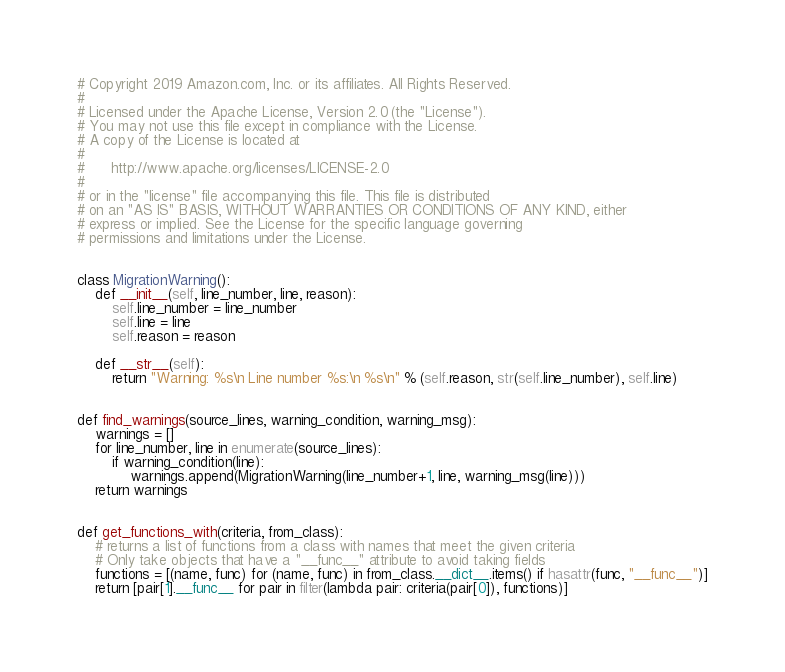<code> <loc_0><loc_0><loc_500><loc_500><_Python_># Copyright 2019 Amazon.com, Inc. or its affiliates. All Rights Reserved.
#
# Licensed under the Apache License, Version 2.0 (the "License").
# You may not use this file except in compliance with the License.
# A copy of the License is located at
#
#      http://www.apache.org/licenses/LICENSE-2.0
#
# or in the "license" file accompanying this file. This file is distributed
# on an "AS IS" BASIS, WITHOUT WARRANTIES OR CONDITIONS OF ANY KIND, either
# express or implied. See the License for the specific language governing
# permissions and limitations under the License.


class MigrationWarning():
    def __init__(self, line_number, line, reason):
        self.line_number = line_number
        self.line = line
        self.reason = reason

    def __str__(self):
        return "Warning: %s\n Line number %s:\n %s\n" % (self.reason, str(self.line_number), self.line)


def find_warnings(source_lines, warning_condition, warning_msg):
    warnings = []
    for line_number, line in enumerate(source_lines):
        if warning_condition(line):
            warnings.append(MigrationWarning(line_number+1, line, warning_msg(line)))
    return warnings


def get_functions_with(criteria, from_class):
    # returns a list of functions from a class with names that meet the given criteria
    # Only take objects that have a "__func__" attribute to avoid taking fields
    functions = [(name, func) for (name, func) in from_class.__dict__.items() if hasattr(func, "__func__")]
    return [pair[1].__func__ for pair in filter(lambda pair: criteria(pair[0]), functions)]
</code> 